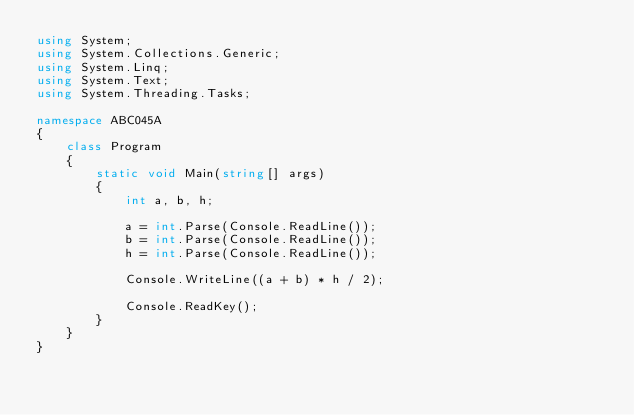Convert code to text. <code><loc_0><loc_0><loc_500><loc_500><_C#_>using System;
using System.Collections.Generic;
using System.Linq;
using System.Text;
using System.Threading.Tasks;

namespace ABC045A
{
    class Program
    {
        static void Main(string[] args)
        {
            int a, b, h;

            a = int.Parse(Console.ReadLine());
            b = int.Parse(Console.ReadLine());
            h = int.Parse(Console.ReadLine());

            Console.WriteLine((a + b) * h / 2);

            Console.ReadKey();
        }
    }
}
</code> 